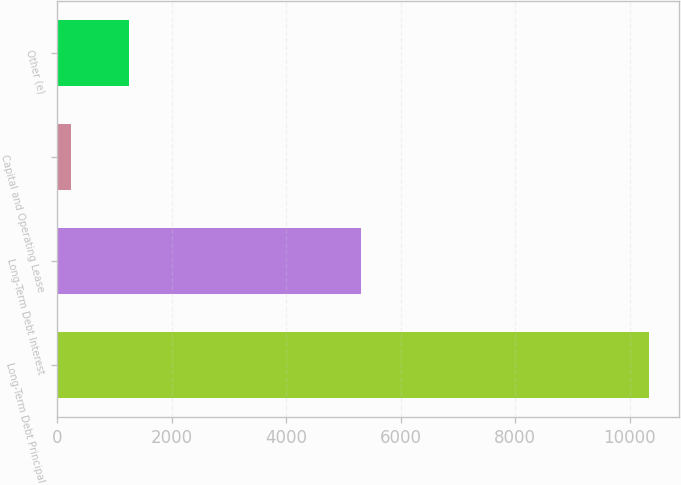Convert chart to OTSL. <chart><loc_0><loc_0><loc_500><loc_500><bar_chart><fcel>Long-Term Debt Principal<fcel>Long-Term Debt Interest<fcel>Capital and Operating Lease<fcel>Other (e)<nl><fcel>10344<fcel>5314<fcel>250<fcel>1259.4<nl></chart> 